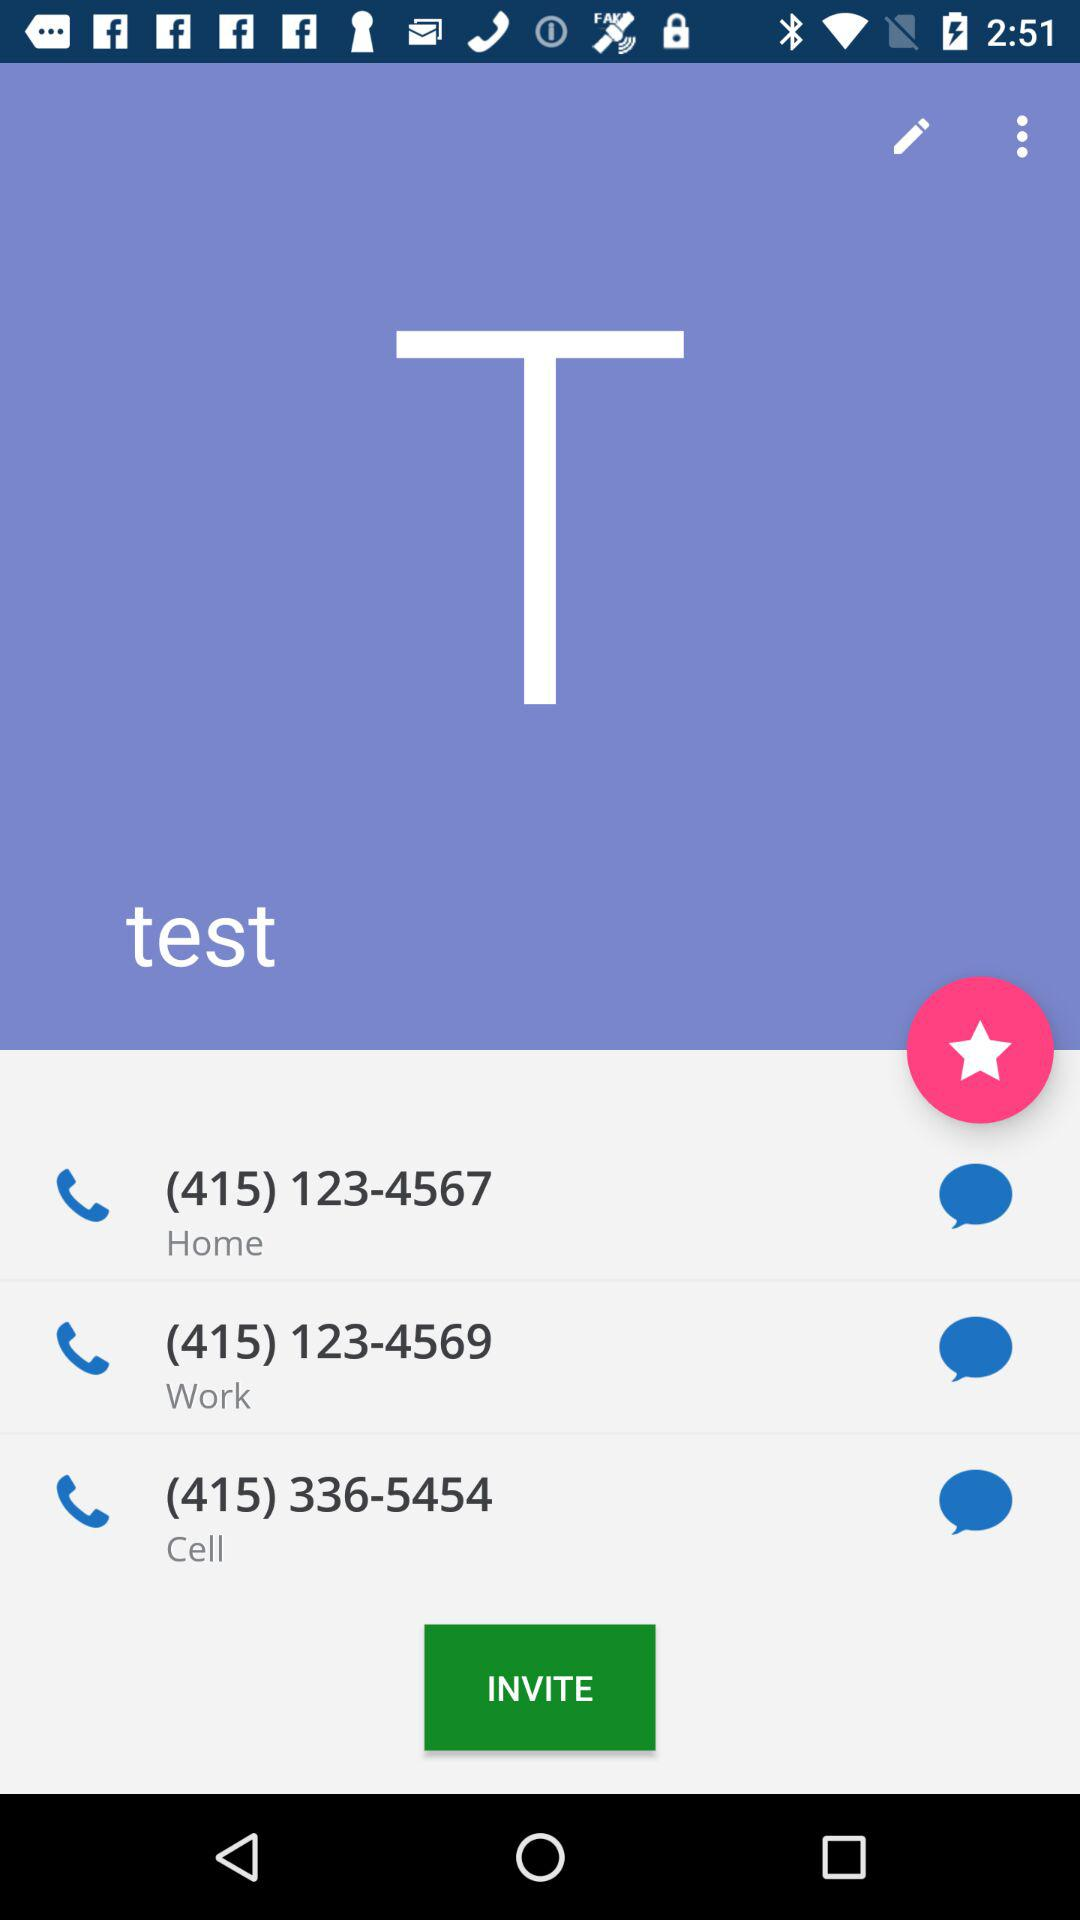What is the phone number for work? The phone number is (415) 123-4569. 